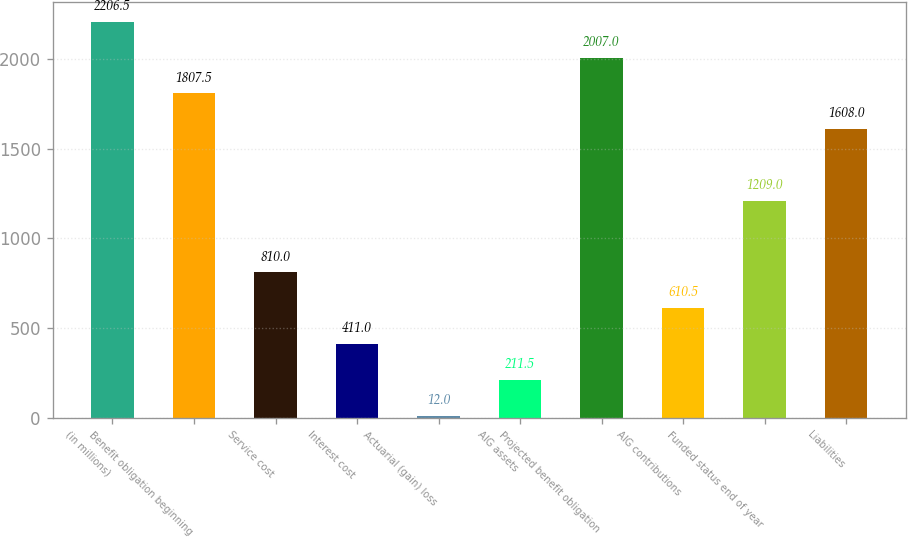<chart> <loc_0><loc_0><loc_500><loc_500><bar_chart><fcel>(in millions)<fcel>Benefit obligation beginning<fcel>Service cost<fcel>Interest cost<fcel>Actuarial (gain) loss<fcel>AIG assets<fcel>Projected benefit obligation<fcel>AIG contributions<fcel>Funded status end of year<fcel>Liabilities<nl><fcel>2206.5<fcel>1807.5<fcel>810<fcel>411<fcel>12<fcel>211.5<fcel>2007<fcel>610.5<fcel>1209<fcel>1608<nl></chart> 